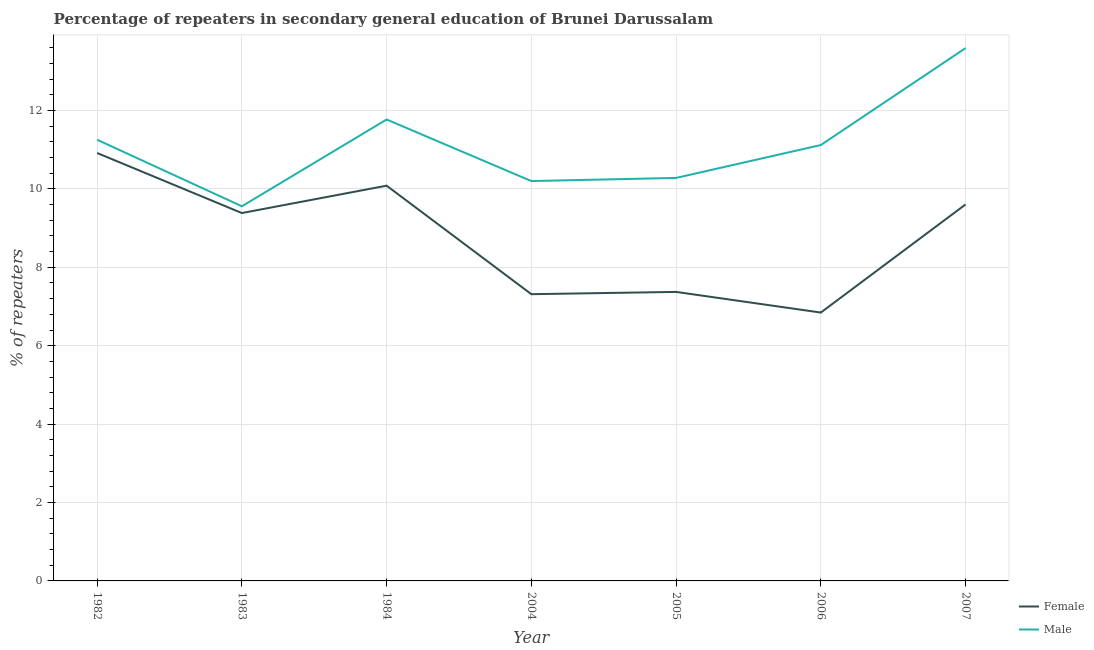Does the line corresponding to percentage of female repeaters intersect with the line corresponding to percentage of male repeaters?
Give a very brief answer. No. What is the percentage of female repeaters in 2006?
Your answer should be compact. 6.85. Across all years, what is the maximum percentage of female repeaters?
Your answer should be compact. 10.92. Across all years, what is the minimum percentage of male repeaters?
Your answer should be compact. 9.56. What is the total percentage of female repeaters in the graph?
Offer a terse response. 61.52. What is the difference between the percentage of female repeaters in 1983 and that in 2007?
Provide a short and direct response. -0.22. What is the difference between the percentage of female repeaters in 2006 and the percentage of male repeaters in 1983?
Offer a very short reply. -2.71. What is the average percentage of male repeaters per year?
Your answer should be very brief. 11.11. In the year 1984, what is the difference between the percentage of female repeaters and percentage of male repeaters?
Offer a very short reply. -1.69. What is the ratio of the percentage of male repeaters in 1982 to that in 2004?
Your answer should be very brief. 1.1. What is the difference between the highest and the second highest percentage of male repeaters?
Keep it short and to the point. 1.82. What is the difference between the highest and the lowest percentage of male repeaters?
Offer a very short reply. 4.04. In how many years, is the percentage of male repeaters greater than the average percentage of male repeaters taken over all years?
Give a very brief answer. 4. Is the sum of the percentage of female repeaters in 1982 and 1984 greater than the maximum percentage of male repeaters across all years?
Your response must be concise. Yes. Does the percentage of male repeaters monotonically increase over the years?
Ensure brevity in your answer.  No. Is the percentage of female repeaters strictly greater than the percentage of male repeaters over the years?
Your answer should be very brief. No. Is the percentage of male repeaters strictly less than the percentage of female repeaters over the years?
Your answer should be very brief. No. Are the values on the major ticks of Y-axis written in scientific E-notation?
Your answer should be compact. No. Does the graph contain any zero values?
Your answer should be very brief. No. Does the graph contain grids?
Your answer should be very brief. Yes. How many legend labels are there?
Your response must be concise. 2. What is the title of the graph?
Your answer should be very brief. Percentage of repeaters in secondary general education of Brunei Darussalam. Does "Official aid received" appear as one of the legend labels in the graph?
Give a very brief answer. No. What is the label or title of the Y-axis?
Provide a short and direct response. % of repeaters. What is the % of repeaters in Female in 1982?
Provide a succinct answer. 10.92. What is the % of repeaters of Male in 1982?
Provide a short and direct response. 11.25. What is the % of repeaters in Female in 1983?
Your answer should be very brief. 9.38. What is the % of repeaters of Male in 1983?
Give a very brief answer. 9.56. What is the % of repeaters of Female in 1984?
Provide a short and direct response. 10.08. What is the % of repeaters of Male in 1984?
Offer a terse response. 11.77. What is the % of repeaters in Female in 2004?
Your response must be concise. 7.31. What is the % of repeaters in Male in 2004?
Ensure brevity in your answer.  10.2. What is the % of repeaters of Female in 2005?
Offer a terse response. 7.37. What is the % of repeaters in Male in 2005?
Offer a very short reply. 10.28. What is the % of repeaters of Female in 2006?
Provide a short and direct response. 6.85. What is the % of repeaters in Male in 2006?
Your response must be concise. 11.12. What is the % of repeaters of Female in 2007?
Make the answer very short. 9.6. What is the % of repeaters in Male in 2007?
Your response must be concise. 13.59. Across all years, what is the maximum % of repeaters in Female?
Your answer should be compact. 10.92. Across all years, what is the maximum % of repeaters of Male?
Ensure brevity in your answer.  13.59. Across all years, what is the minimum % of repeaters of Female?
Offer a terse response. 6.85. Across all years, what is the minimum % of repeaters of Male?
Provide a succinct answer. 9.56. What is the total % of repeaters in Female in the graph?
Give a very brief answer. 61.52. What is the total % of repeaters in Male in the graph?
Give a very brief answer. 77.77. What is the difference between the % of repeaters of Female in 1982 and that in 1983?
Provide a short and direct response. 1.53. What is the difference between the % of repeaters of Male in 1982 and that in 1983?
Your answer should be compact. 1.7. What is the difference between the % of repeaters in Female in 1982 and that in 1984?
Provide a succinct answer. 0.83. What is the difference between the % of repeaters of Male in 1982 and that in 1984?
Offer a terse response. -0.52. What is the difference between the % of repeaters of Female in 1982 and that in 2004?
Provide a short and direct response. 3.6. What is the difference between the % of repeaters of Male in 1982 and that in 2004?
Offer a very short reply. 1.05. What is the difference between the % of repeaters in Female in 1982 and that in 2005?
Ensure brevity in your answer.  3.54. What is the difference between the % of repeaters of Male in 1982 and that in 2005?
Your response must be concise. 0.97. What is the difference between the % of repeaters of Female in 1982 and that in 2006?
Provide a short and direct response. 4.07. What is the difference between the % of repeaters of Male in 1982 and that in 2006?
Offer a very short reply. 0.14. What is the difference between the % of repeaters of Female in 1982 and that in 2007?
Provide a short and direct response. 1.31. What is the difference between the % of repeaters in Male in 1982 and that in 2007?
Your response must be concise. -2.34. What is the difference between the % of repeaters of Female in 1983 and that in 1984?
Offer a very short reply. -0.7. What is the difference between the % of repeaters in Male in 1983 and that in 1984?
Make the answer very short. -2.21. What is the difference between the % of repeaters of Female in 1983 and that in 2004?
Your response must be concise. 2.07. What is the difference between the % of repeaters of Male in 1983 and that in 2004?
Make the answer very short. -0.64. What is the difference between the % of repeaters in Female in 1983 and that in 2005?
Offer a very short reply. 2.01. What is the difference between the % of repeaters of Male in 1983 and that in 2005?
Your answer should be very brief. -0.72. What is the difference between the % of repeaters in Female in 1983 and that in 2006?
Your answer should be very brief. 2.54. What is the difference between the % of repeaters in Male in 1983 and that in 2006?
Make the answer very short. -1.56. What is the difference between the % of repeaters of Female in 1983 and that in 2007?
Offer a terse response. -0.22. What is the difference between the % of repeaters in Male in 1983 and that in 2007?
Keep it short and to the point. -4.04. What is the difference between the % of repeaters of Female in 1984 and that in 2004?
Your response must be concise. 2.77. What is the difference between the % of repeaters of Male in 1984 and that in 2004?
Your response must be concise. 1.57. What is the difference between the % of repeaters in Female in 1984 and that in 2005?
Ensure brevity in your answer.  2.71. What is the difference between the % of repeaters in Male in 1984 and that in 2005?
Your answer should be very brief. 1.49. What is the difference between the % of repeaters in Female in 1984 and that in 2006?
Keep it short and to the point. 3.24. What is the difference between the % of repeaters of Male in 1984 and that in 2006?
Give a very brief answer. 0.65. What is the difference between the % of repeaters of Female in 1984 and that in 2007?
Offer a terse response. 0.48. What is the difference between the % of repeaters of Male in 1984 and that in 2007?
Give a very brief answer. -1.82. What is the difference between the % of repeaters in Female in 2004 and that in 2005?
Offer a very short reply. -0.06. What is the difference between the % of repeaters of Male in 2004 and that in 2005?
Keep it short and to the point. -0.08. What is the difference between the % of repeaters of Female in 2004 and that in 2006?
Offer a terse response. 0.47. What is the difference between the % of repeaters in Male in 2004 and that in 2006?
Your response must be concise. -0.92. What is the difference between the % of repeaters in Female in 2004 and that in 2007?
Offer a terse response. -2.29. What is the difference between the % of repeaters of Male in 2004 and that in 2007?
Your answer should be compact. -3.39. What is the difference between the % of repeaters of Female in 2005 and that in 2006?
Your answer should be very brief. 0.53. What is the difference between the % of repeaters in Male in 2005 and that in 2006?
Keep it short and to the point. -0.84. What is the difference between the % of repeaters of Female in 2005 and that in 2007?
Give a very brief answer. -2.23. What is the difference between the % of repeaters in Male in 2005 and that in 2007?
Your answer should be compact. -3.31. What is the difference between the % of repeaters in Female in 2006 and that in 2007?
Offer a very short reply. -2.76. What is the difference between the % of repeaters of Male in 2006 and that in 2007?
Give a very brief answer. -2.47. What is the difference between the % of repeaters of Female in 1982 and the % of repeaters of Male in 1983?
Your answer should be compact. 1.36. What is the difference between the % of repeaters in Female in 1982 and the % of repeaters in Male in 1984?
Offer a very short reply. -0.85. What is the difference between the % of repeaters of Female in 1982 and the % of repeaters of Male in 2004?
Provide a short and direct response. 0.72. What is the difference between the % of repeaters of Female in 1982 and the % of repeaters of Male in 2005?
Your response must be concise. 0.64. What is the difference between the % of repeaters in Female in 1982 and the % of repeaters in Male in 2006?
Provide a short and direct response. -0.2. What is the difference between the % of repeaters in Female in 1982 and the % of repeaters in Male in 2007?
Give a very brief answer. -2.68. What is the difference between the % of repeaters of Female in 1983 and the % of repeaters of Male in 1984?
Provide a succinct answer. -2.39. What is the difference between the % of repeaters of Female in 1983 and the % of repeaters of Male in 2004?
Make the answer very short. -0.82. What is the difference between the % of repeaters in Female in 1983 and the % of repeaters in Male in 2005?
Ensure brevity in your answer.  -0.9. What is the difference between the % of repeaters of Female in 1983 and the % of repeaters of Male in 2006?
Offer a very short reply. -1.73. What is the difference between the % of repeaters in Female in 1983 and the % of repeaters in Male in 2007?
Keep it short and to the point. -4.21. What is the difference between the % of repeaters of Female in 1984 and the % of repeaters of Male in 2004?
Ensure brevity in your answer.  -0.12. What is the difference between the % of repeaters in Female in 1984 and the % of repeaters in Male in 2005?
Offer a terse response. -0.2. What is the difference between the % of repeaters in Female in 1984 and the % of repeaters in Male in 2006?
Make the answer very short. -1.04. What is the difference between the % of repeaters in Female in 1984 and the % of repeaters in Male in 2007?
Offer a very short reply. -3.51. What is the difference between the % of repeaters in Female in 2004 and the % of repeaters in Male in 2005?
Offer a terse response. -2.97. What is the difference between the % of repeaters of Female in 2004 and the % of repeaters of Male in 2006?
Offer a terse response. -3.8. What is the difference between the % of repeaters of Female in 2004 and the % of repeaters of Male in 2007?
Your answer should be compact. -6.28. What is the difference between the % of repeaters of Female in 2005 and the % of repeaters of Male in 2006?
Keep it short and to the point. -3.75. What is the difference between the % of repeaters in Female in 2005 and the % of repeaters in Male in 2007?
Provide a short and direct response. -6.22. What is the difference between the % of repeaters of Female in 2006 and the % of repeaters of Male in 2007?
Offer a terse response. -6.75. What is the average % of repeaters in Female per year?
Your answer should be very brief. 8.79. What is the average % of repeaters of Male per year?
Make the answer very short. 11.11. In the year 1982, what is the difference between the % of repeaters in Female and % of repeaters in Male?
Provide a succinct answer. -0.34. In the year 1983, what is the difference between the % of repeaters of Female and % of repeaters of Male?
Provide a short and direct response. -0.17. In the year 1984, what is the difference between the % of repeaters in Female and % of repeaters in Male?
Offer a terse response. -1.69. In the year 2004, what is the difference between the % of repeaters of Female and % of repeaters of Male?
Your answer should be compact. -2.89. In the year 2005, what is the difference between the % of repeaters in Female and % of repeaters in Male?
Ensure brevity in your answer.  -2.91. In the year 2006, what is the difference between the % of repeaters in Female and % of repeaters in Male?
Offer a terse response. -4.27. In the year 2007, what is the difference between the % of repeaters in Female and % of repeaters in Male?
Provide a short and direct response. -3.99. What is the ratio of the % of repeaters of Female in 1982 to that in 1983?
Offer a very short reply. 1.16. What is the ratio of the % of repeaters in Male in 1982 to that in 1983?
Keep it short and to the point. 1.18. What is the ratio of the % of repeaters of Female in 1982 to that in 1984?
Make the answer very short. 1.08. What is the ratio of the % of repeaters of Male in 1982 to that in 1984?
Your answer should be very brief. 0.96. What is the ratio of the % of repeaters in Female in 1982 to that in 2004?
Ensure brevity in your answer.  1.49. What is the ratio of the % of repeaters in Male in 1982 to that in 2004?
Make the answer very short. 1.1. What is the ratio of the % of repeaters in Female in 1982 to that in 2005?
Make the answer very short. 1.48. What is the ratio of the % of repeaters of Male in 1982 to that in 2005?
Your answer should be very brief. 1.09. What is the ratio of the % of repeaters in Female in 1982 to that in 2006?
Offer a very short reply. 1.59. What is the ratio of the % of repeaters of Male in 1982 to that in 2006?
Keep it short and to the point. 1.01. What is the ratio of the % of repeaters of Female in 1982 to that in 2007?
Your answer should be very brief. 1.14. What is the ratio of the % of repeaters of Male in 1982 to that in 2007?
Offer a very short reply. 0.83. What is the ratio of the % of repeaters of Female in 1983 to that in 1984?
Your answer should be compact. 0.93. What is the ratio of the % of repeaters in Male in 1983 to that in 1984?
Your answer should be compact. 0.81. What is the ratio of the % of repeaters of Female in 1983 to that in 2004?
Provide a short and direct response. 1.28. What is the ratio of the % of repeaters of Male in 1983 to that in 2004?
Make the answer very short. 0.94. What is the ratio of the % of repeaters in Female in 1983 to that in 2005?
Ensure brevity in your answer.  1.27. What is the ratio of the % of repeaters in Male in 1983 to that in 2005?
Provide a short and direct response. 0.93. What is the ratio of the % of repeaters of Female in 1983 to that in 2006?
Ensure brevity in your answer.  1.37. What is the ratio of the % of repeaters in Male in 1983 to that in 2006?
Provide a succinct answer. 0.86. What is the ratio of the % of repeaters of Female in 1983 to that in 2007?
Provide a short and direct response. 0.98. What is the ratio of the % of repeaters of Male in 1983 to that in 2007?
Give a very brief answer. 0.7. What is the ratio of the % of repeaters of Female in 1984 to that in 2004?
Your answer should be very brief. 1.38. What is the ratio of the % of repeaters in Male in 1984 to that in 2004?
Offer a very short reply. 1.15. What is the ratio of the % of repeaters of Female in 1984 to that in 2005?
Make the answer very short. 1.37. What is the ratio of the % of repeaters in Male in 1984 to that in 2005?
Provide a succinct answer. 1.15. What is the ratio of the % of repeaters of Female in 1984 to that in 2006?
Your response must be concise. 1.47. What is the ratio of the % of repeaters of Male in 1984 to that in 2006?
Ensure brevity in your answer.  1.06. What is the ratio of the % of repeaters in Female in 1984 to that in 2007?
Provide a succinct answer. 1.05. What is the ratio of the % of repeaters of Male in 1984 to that in 2007?
Provide a succinct answer. 0.87. What is the ratio of the % of repeaters in Male in 2004 to that in 2005?
Provide a short and direct response. 0.99. What is the ratio of the % of repeaters in Female in 2004 to that in 2006?
Provide a short and direct response. 1.07. What is the ratio of the % of repeaters of Male in 2004 to that in 2006?
Provide a succinct answer. 0.92. What is the ratio of the % of repeaters in Female in 2004 to that in 2007?
Give a very brief answer. 0.76. What is the ratio of the % of repeaters in Male in 2004 to that in 2007?
Your answer should be very brief. 0.75. What is the ratio of the % of repeaters of Female in 2005 to that in 2006?
Your answer should be very brief. 1.08. What is the ratio of the % of repeaters of Male in 2005 to that in 2006?
Provide a succinct answer. 0.92. What is the ratio of the % of repeaters in Female in 2005 to that in 2007?
Ensure brevity in your answer.  0.77. What is the ratio of the % of repeaters in Male in 2005 to that in 2007?
Give a very brief answer. 0.76. What is the ratio of the % of repeaters in Female in 2006 to that in 2007?
Offer a very short reply. 0.71. What is the ratio of the % of repeaters in Male in 2006 to that in 2007?
Give a very brief answer. 0.82. What is the difference between the highest and the second highest % of repeaters in Male?
Offer a very short reply. 1.82. What is the difference between the highest and the lowest % of repeaters in Female?
Your answer should be compact. 4.07. What is the difference between the highest and the lowest % of repeaters in Male?
Keep it short and to the point. 4.04. 